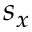<formula> <loc_0><loc_0><loc_500><loc_500>s _ { x }</formula> 